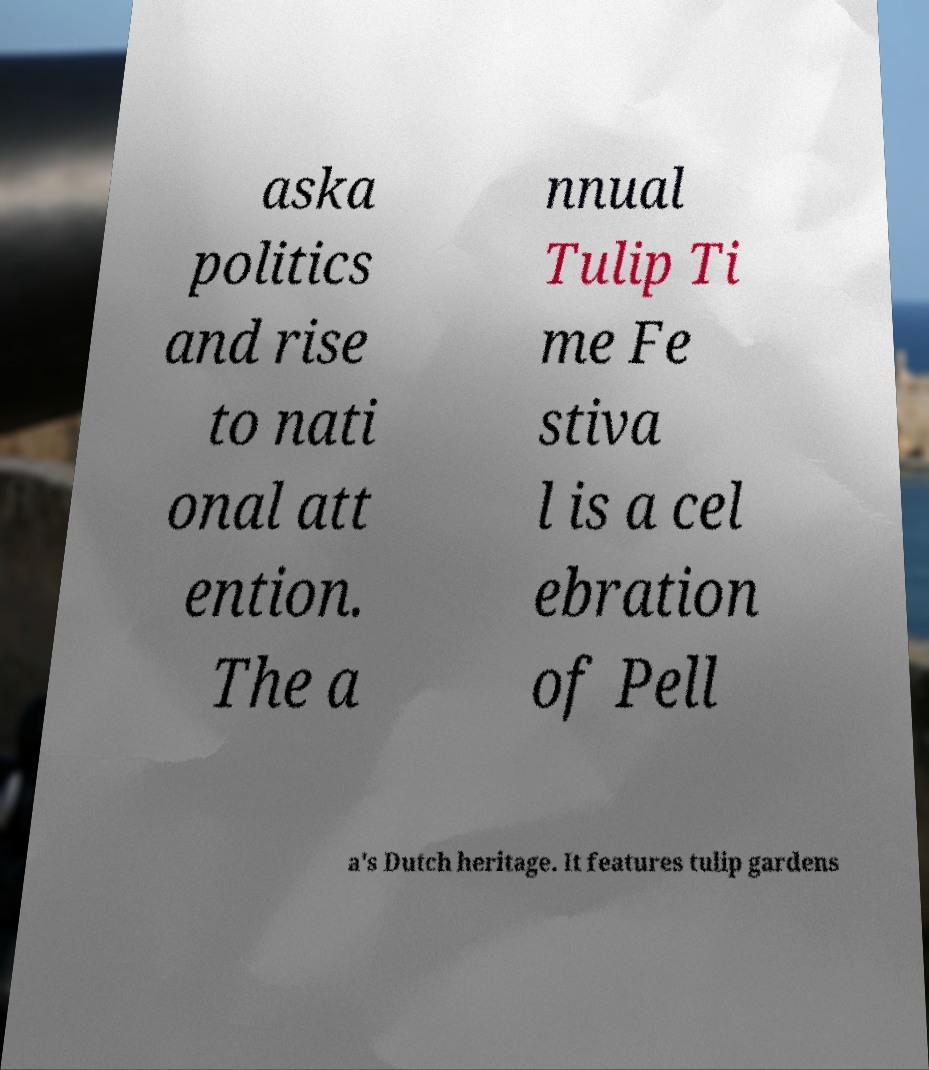Please identify and transcribe the text found in this image. aska politics and rise to nati onal att ention. The a nnual Tulip Ti me Fe stiva l is a cel ebration of Pell a's Dutch heritage. It features tulip gardens 